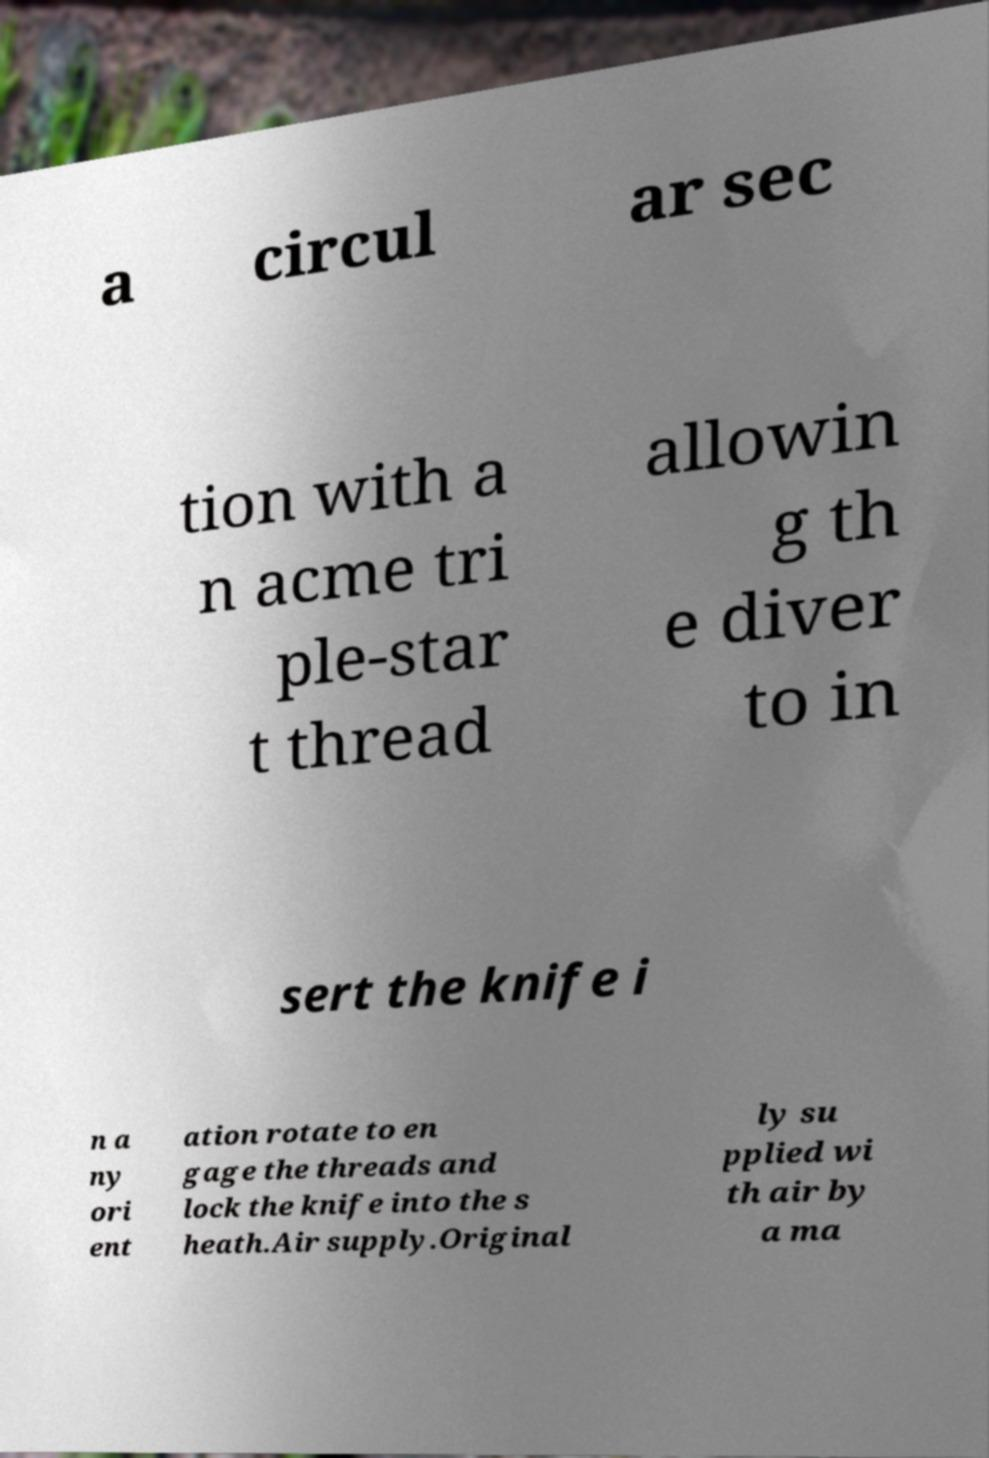There's text embedded in this image that I need extracted. Can you transcribe it verbatim? a circul ar sec tion with a n acme tri ple-star t thread allowin g th e diver to in sert the knife i n a ny ori ent ation rotate to en gage the threads and lock the knife into the s heath.Air supply.Original ly su pplied wi th air by a ma 